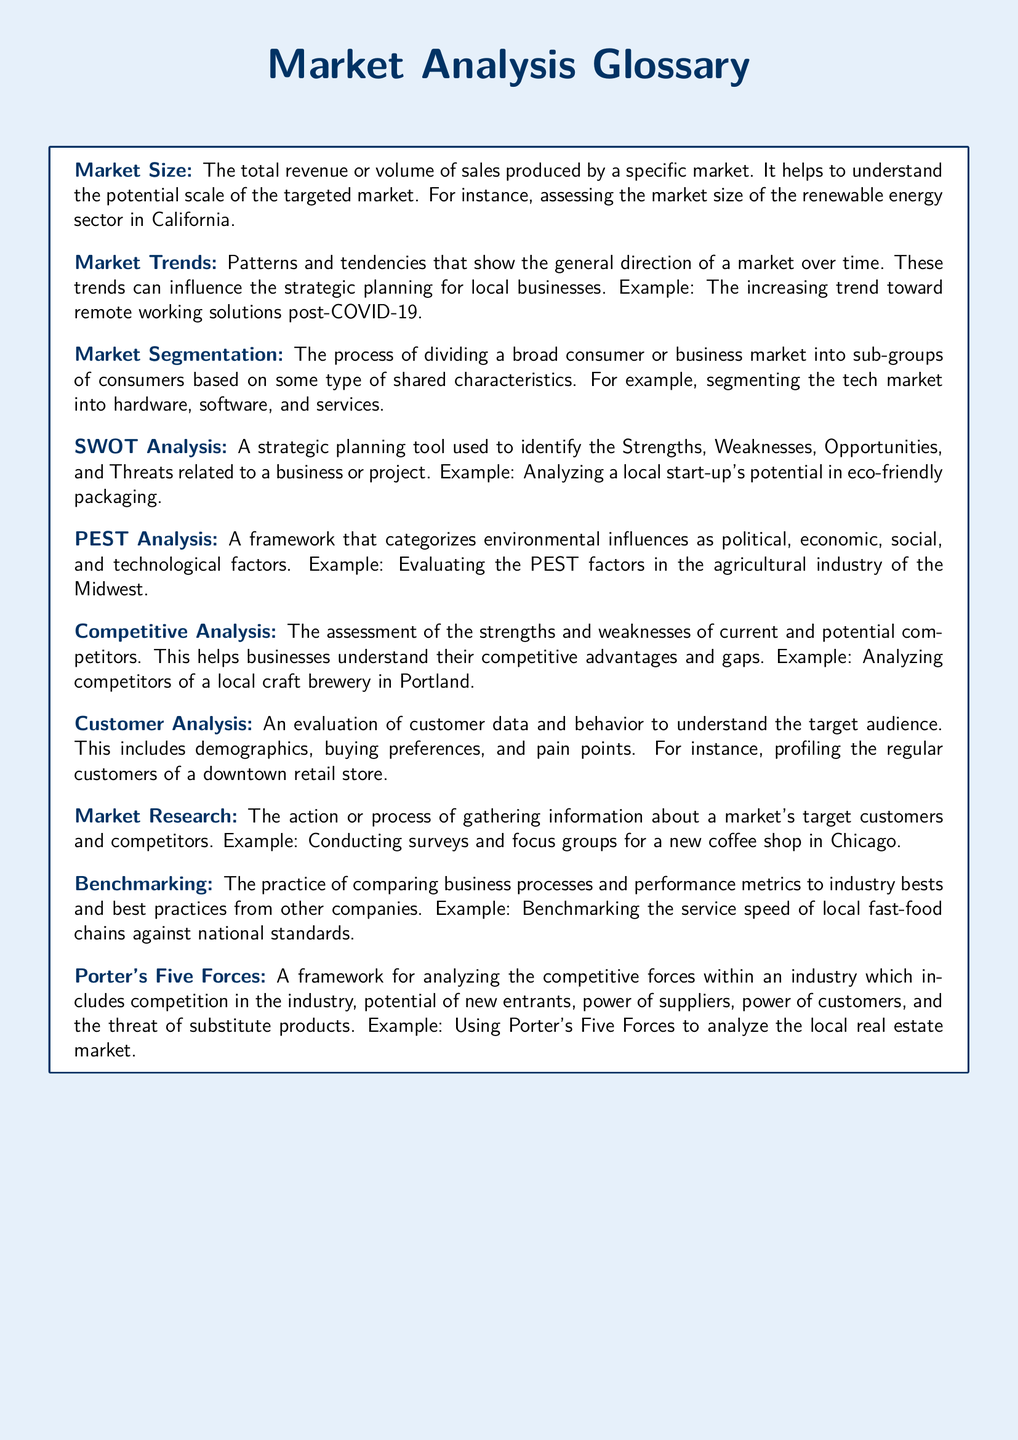What is the total revenue produced by a specific market? The total revenue produced by a specific market is referred to as Market Size in the document.
Answer: Market Size What analysis is used to identify Strengths, Weaknesses, Opportunities, and Threats? This type of analysis is known as SWOT Analysis as mentioned in the document.
Answer: SWOT Analysis What framework categorizes environmental influences? The framework that categorizes environmental influences is called PEST Analysis according to the document.
Answer: PEST Analysis What is the increasing trend mentioned post-COVID-19? The document mentions the increasing trend toward remote working solutions after COVID-19.
Answer: Remote working solutions Which analysis helps businesses understand their competitive advantages? Competitive Analysis is the process that helps businesses understand their competitive advantages as outlined in the document.
Answer: Competitive Analysis What does the Customer Analysis evaluate? Customer Analysis evaluates customer data and behavior to understand the target audience as explained in the document.
Answer: Customer data and behavior What is the action of gathering information about a market's target customers called? The action described in the document is referred to as Market Research.
Answer: Market Research What practice compares business processes to industry standards? The practice of comparing business processes is known as Benchmarking according to the document.
Answer: Benchmarking What framework analyzes the competitive forces within an industry? The framework that analyzes competitive forces in an industry is Porter's Five Forces as mentioned in the document.
Answer: Porter's Five Forces 